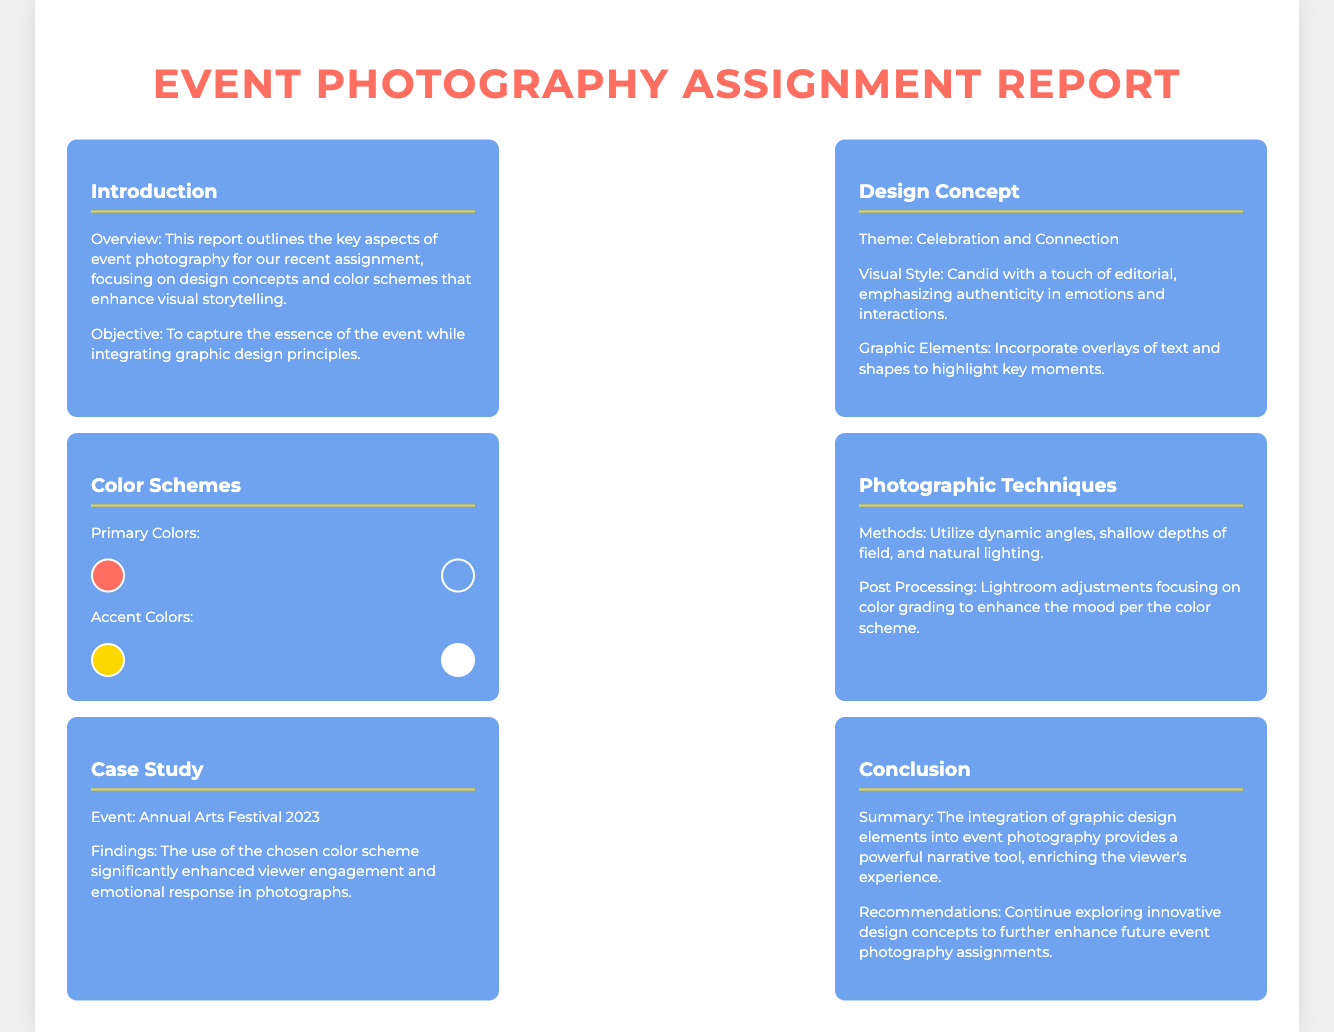What is the theme of the design concept? The theme is stated in the design concept section of the document as "Celebration and Connection."
Answer: Celebration and Connection What are the primary colors listed? The primary colors are specified in the color schemes section, including color boxes representing the colors.
Answer: #FF6F61, #6FA3EF What is the objective of the report? The objective is provided in the introduction section, which points to capturing the essence of the event while integrating graphic design principles.
Answer: To capture the essence of the event while integrating graphic design principles What photographic techniques are mentioned? The techniques are outlined in the photographic techniques section, indicating the methods used for the assignment.
Answer: Dynamic angles, shallow depths of field, and natural lighting Which event is discussed in the case study? The case study includes information about the specific event analyzed, which is identified in that section of the report.
Answer: Annual Arts Festival 2023 What accent colors are used in the report? The accent colors are listed in the color schemes section, represented by color boxes.
Answer: #FFD700, #FFFFFF How does the report summarize the integration of graphic design elements? The conclusion summarizes the integration of graphic design elements as a powerful narrative tool.
Answer: A powerful narrative tool What is recommended for future photography assignments? Recommendations for future assignments are provided in the conclusion section, suggesting areas for exploration.
Answer: Continue exploring innovative design concepts 